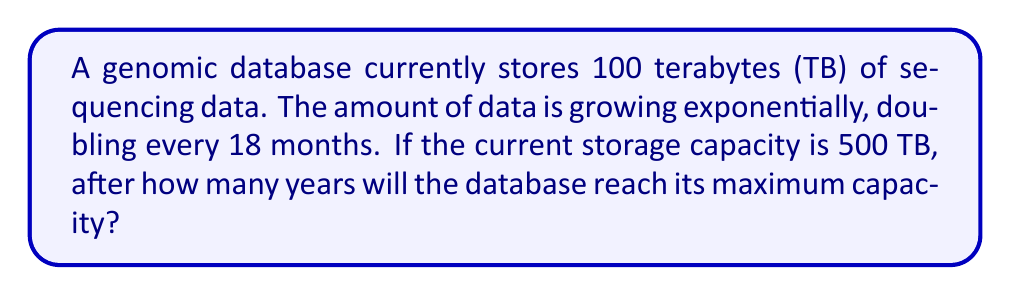Teach me how to tackle this problem. Let's approach this step-by-step:

1) First, we need to set up our exponential growth function. The general form is:

   $A(t) = A_0 \cdot 2^{\frac{t}{T}}$

   Where:
   $A(t)$ is the amount at time $t$
   $A_0$ is the initial amount
   $t$ is the time
   $T$ is the doubling time

2) We know:
   $A_0 = 100$ TB
   $T = 1.5$ years (18 months)

3) We want to find when $A(t) = 500$ TB (the maximum capacity)

4) Let's substitute these into our equation:

   $500 = 100 \cdot 2^{\frac{t}{1.5}}$

5) Now we solve for $t$:

   $\frac{500}{100} = 2^{\frac{t}{1.5}}$
   $5 = 2^{\frac{t}{1.5}}$

6) Take the logarithm (base 2) of both sides:

   $\log_2(5) = \frac{t}{1.5}$

7) Solve for $t$:

   $t = 1.5 \cdot \log_2(5)$

8) Calculate:
   $\log_2(5) \approx 2.3219$
   $t \approx 1.5 \cdot 2.3219 \approx 3.4829$ years

9) Round to two decimal places:
   $t \approx 3.48$ years
Answer: 3.48 years 